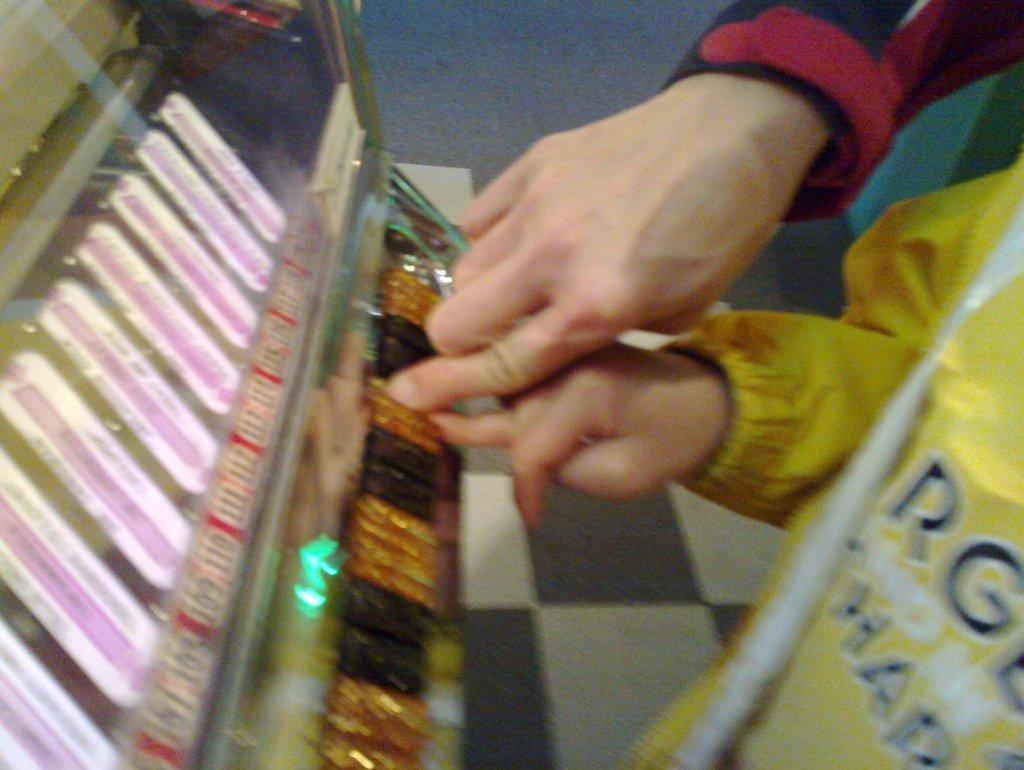What can be seen in the image involving two people? There are hands of two persons in the image. What is located in front of the two persons? There is a machine in front of the two persons. What word can be seen on the machine in the image? There is no word visible on the machine in the image. How does the group of people look in the image? There is no group of people in the image; only the hands of two persons are visible. 